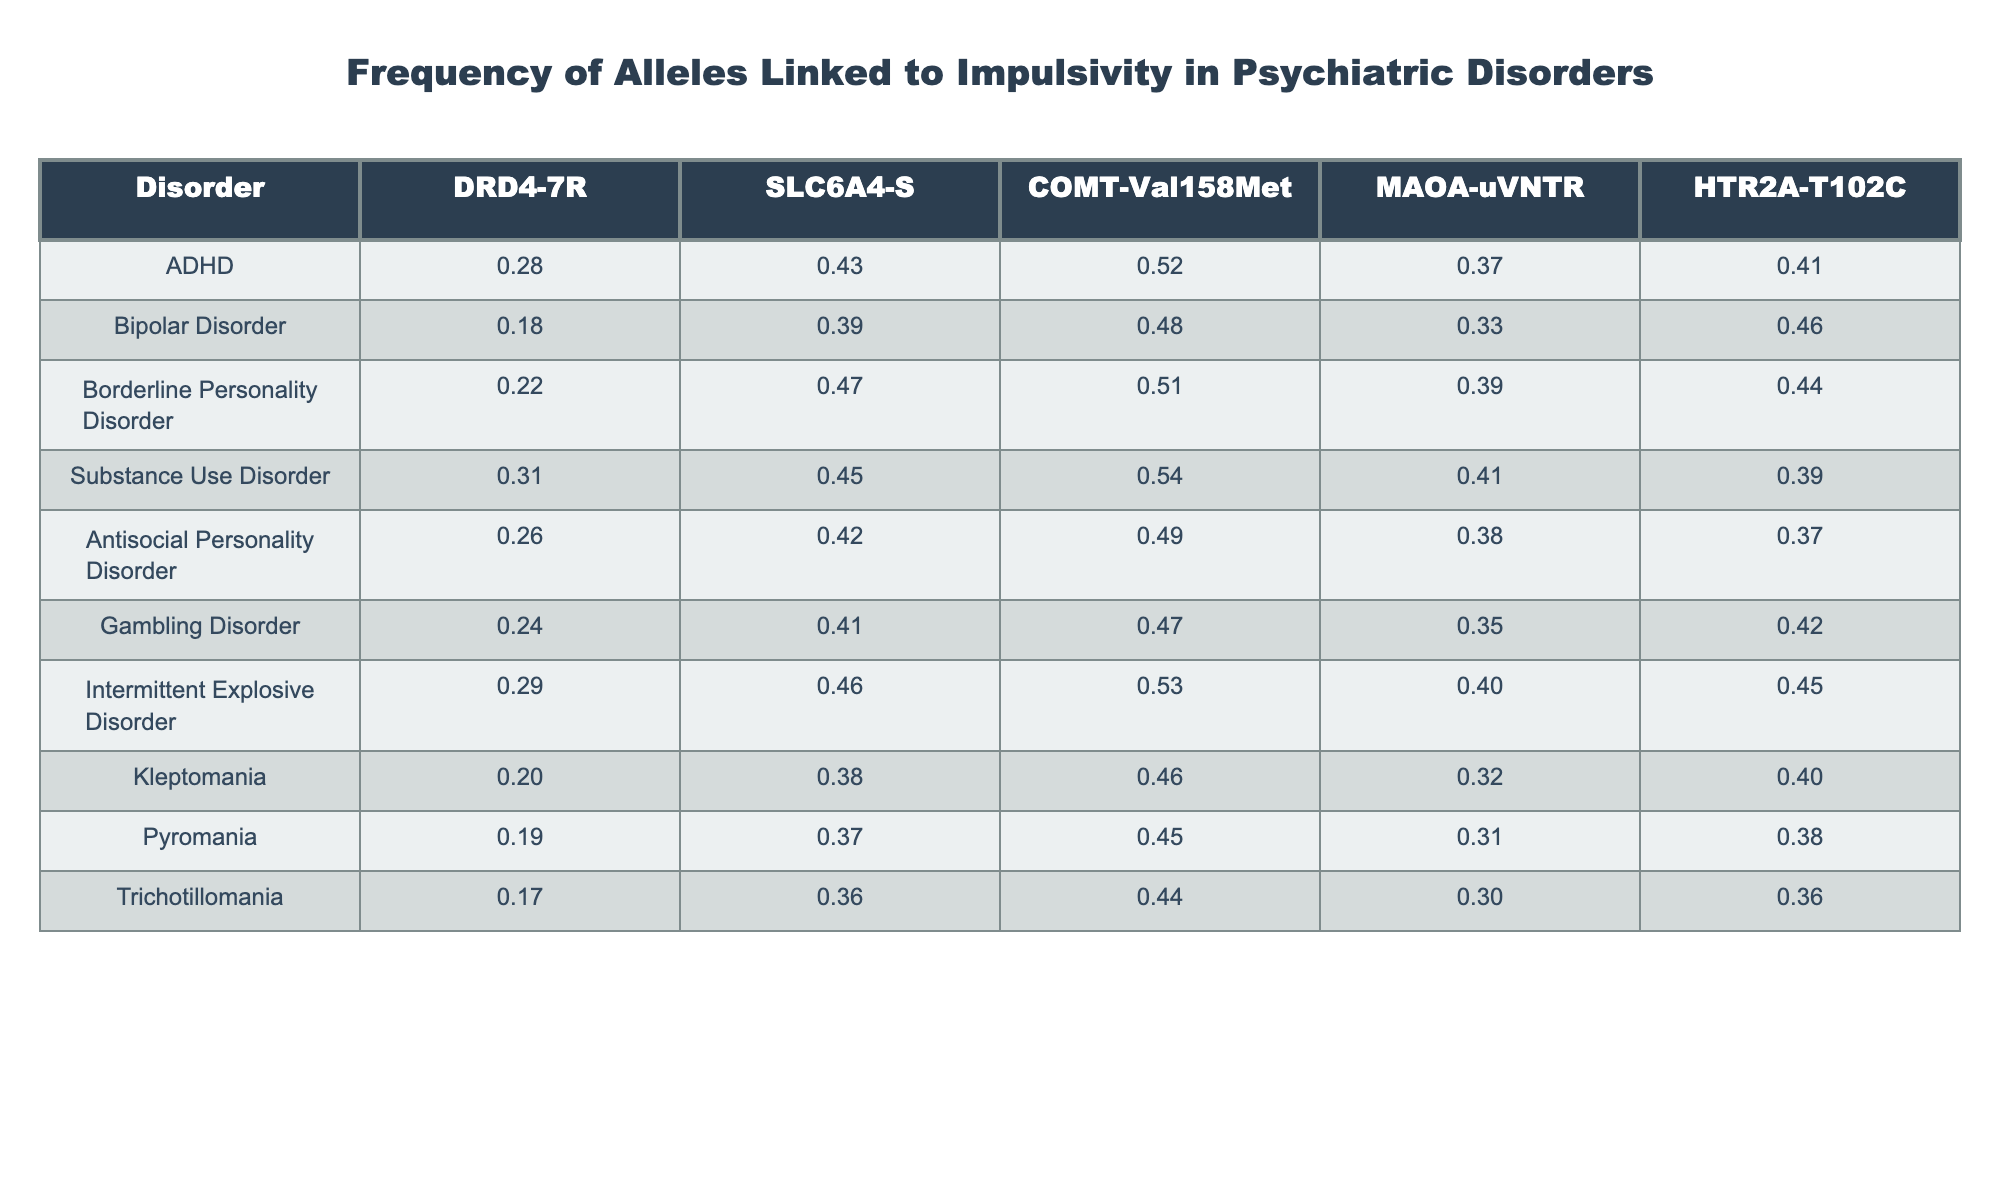What is the frequency of the DRD4-7R allele in Substance Use Disorder? In the table, the value under the DRD4-7R column for Substance Use Disorder can be directly found, which is 0.31.
Answer: 0.31 Which disorder shows the highest frequency of the SLC6A4-S allele? By examining the SLC6A4-S column, the highest value is 0.47, which corresponds to Borderline Personality Disorder.
Answer: Borderline Personality Disorder What is the average frequency of the COMT-Val158Met allele across all disorders? We sum all the values in the COMT-Val158Met column (0.52 + 0.48 + 0.51 + 0.54 + 0.49 + 0.47 + 0.53 + 0.46 + 0.45 + 0.44) = 5.45. There are 10 disorders, so the average is 5.45 / 10 = 0.545.
Answer: 0.545 Is the frequency of the MAOA-uVNTR allele in Bipolar Disorder greater than that in Kleptomania? The MAOA-uVNTR frequency for Bipolar Disorder is 0.33, while for Kleptomania, it is 0.32. Since 0.33 is greater than 0.32, the answer is yes.
Answer: Yes What is the difference in frequency of the HTR2A-T102C allele between ADHD and Antisocial Personality Disorder? The frequency for ADHD is 0.41 and for Antisocial Personality Disorder is 0.37. The difference is calculated as 0.41 - 0.37 = 0.04.
Answer: 0.04 Which disorder has the lowest frequency for the DRD4-7R allele and what is that frequency? Looking through the DRD4-7R column, the lowest value is 0.17, which corresponds to Trichotillomania.
Answer: Trichotillomania, 0.17 If we combine the frequencies of the SLC6A4-S allele in Intermittent Explosive Disorder and Gambling Disorder, what is the total? The frequencies for SLC6A4-S in each disorder are 0.46 (Intermittent Explosive Disorder) and 0.41 (Gambling Disorder). Adding these gives 0.46 + 0.41 = 0.87.
Answer: 0.87 What is the most common allele frequency among the psychiatric disorders listed in the table? Assessing the highest frequency across all columns and rows, the value 0.54 for Substance Use Disorder under the COMT-Val158Met allele is the most common.
Answer: 0.54 Does Pyromania have a higher frequency of the HTR2A-T102C allele compared to ADHD? The frequency for Pyromania is 0.38, while ADHD has a frequency of 0.41. Since 0.38 is less than 0.41, the answer is no.
Answer: No What is the median frequency of the DRD4-7R allele across all disorders? Arranging the DRD4-7R frequencies in ascending order gives us: 0.17, 0.18, 0.19, 0.20, 0.22, 0.24, 0.26, 0.28, 0.29, 0.31. The median is the average of the 5th and 6th values: (0.22 + 0.24) / 2 = 0.23.
Answer: 0.23 